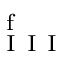Convert formula to latex. <formula><loc_0><loc_0><loc_500><loc_500>_ { I } I I ^ { f }</formula> 